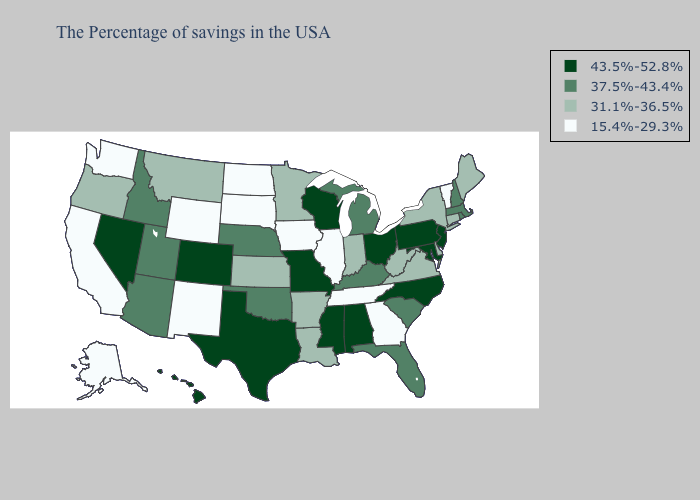Does the map have missing data?
Concise answer only. No. Does Vermont have the lowest value in the Northeast?
Keep it brief. Yes. Among the states that border California , which have the lowest value?
Keep it brief. Oregon. What is the highest value in the MidWest ?
Give a very brief answer. 43.5%-52.8%. What is the lowest value in the USA?
Be succinct. 15.4%-29.3%. What is the lowest value in the MidWest?
Concise answer only. 15.4%-29.3%. What is the value of Florida?
Keep it brief. 37.5%-43.4%. What is the lowest value in the USA?
Concise answer only. 15.4%-29.3%. Does Washington have the highest value in the USA?
Answer briefly. No. Which states have the highest value in the USA?
Quick response, please. New Jersey, Maryland, Pennsylvania, North Carolina, Ohio, Alabama, Wisconsin, Mississippi, Missouri, Texas, Colorado, Nevada, Hawaii. What is the value of Missouri?
Answer briefly. 43.5%-52.8%. Does Idaho have a lower value than Nevada?
Short answer required. Yes. Name the states that have a value in the range 43.5%-52.8%?
Concise answer only. New Jersey, Maryland, Pennsylvania, North Carolina, Ohio, Alabama, Wisconsin, Mississippi, Missouri, Texas, Colorado, Nevada, Hawaii. What is the value of Washington?
Answer briefly. 15.4%-29.3%. What is the value of Tennessee?
Give a very brief answer. 15.4%-29.3%. 